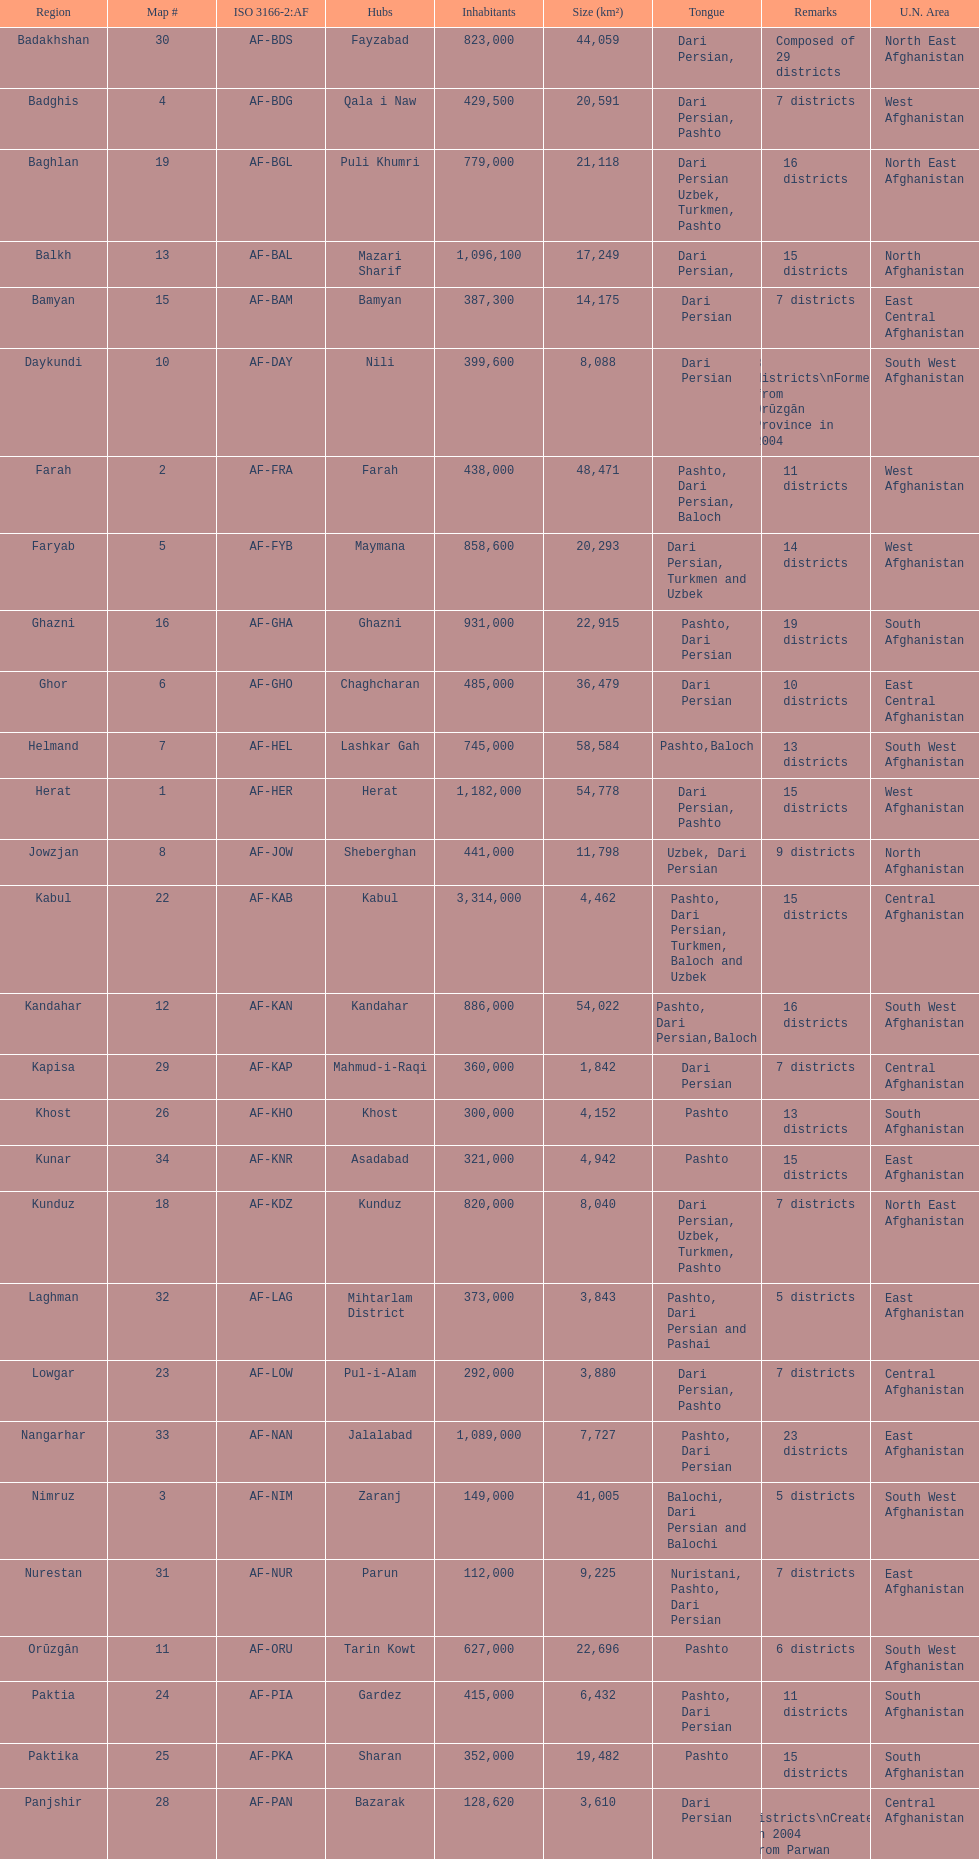Could you enumerate the languages used by the population of 1,182,000 in herat? Dari Persian, Pashto. 